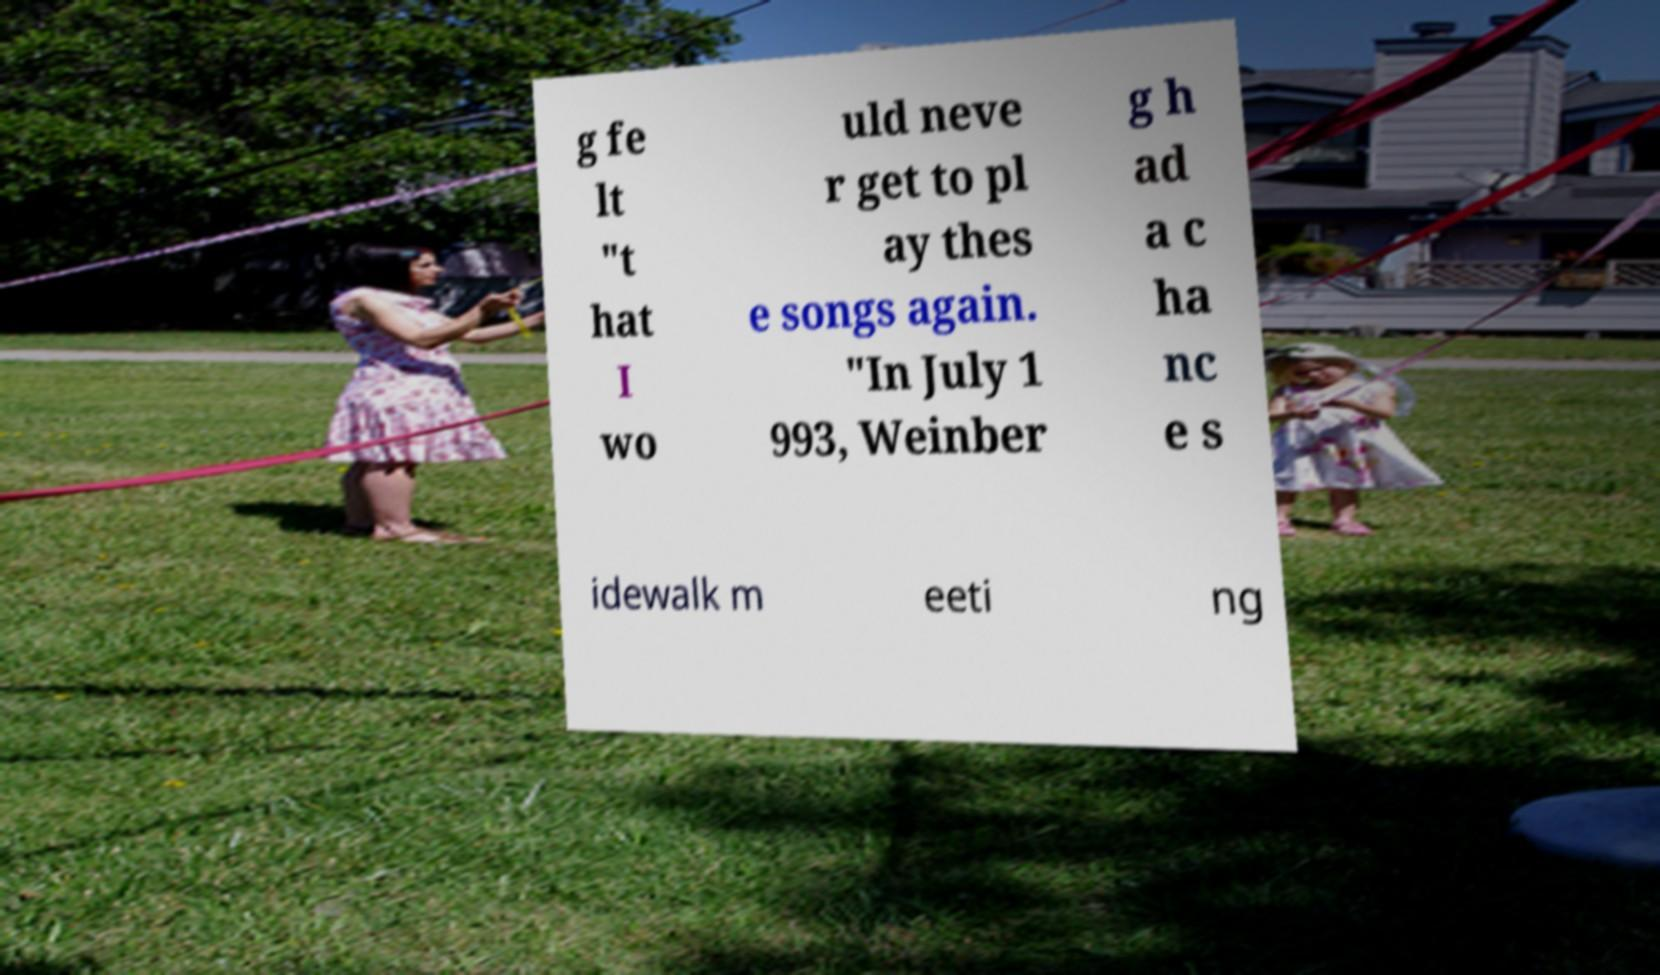I need the written content from this picture converted into text. Can you do that? g fe lt "t hat I wo uld neve r get to pl ay thes e songs again. "In July 1 993, Weinber g h ad a c ha nc e s idewalk m eeti ng 